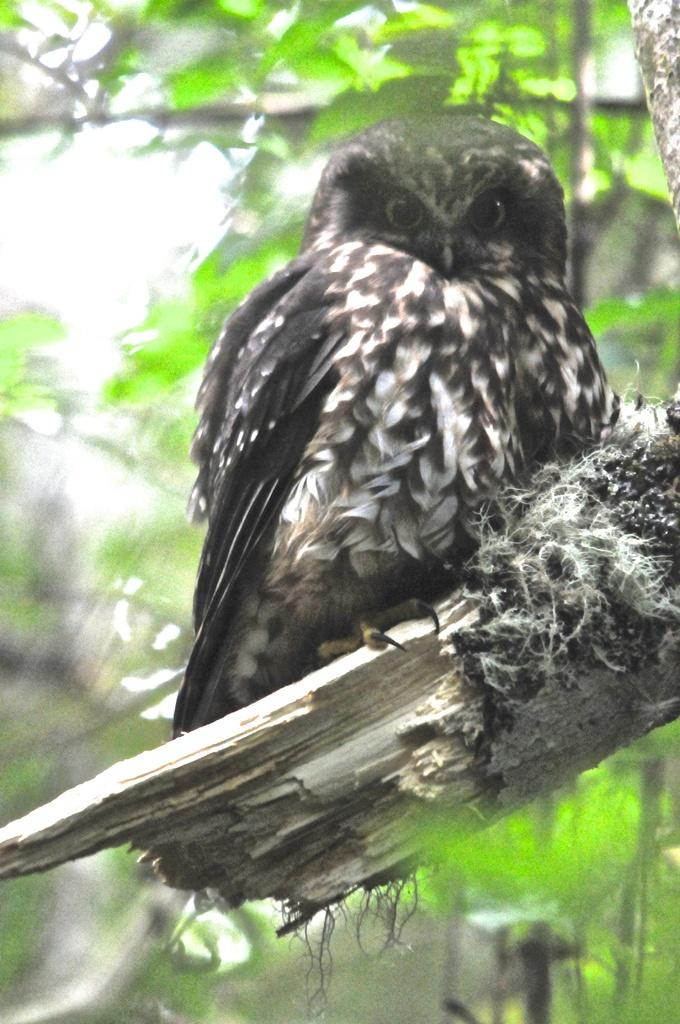What type of animal can be seen in the image? There is a bird in the image. What is the bird perched on? The bird is perched on a branch in the image. Can you describe the background of the image? The background of the image is blurry. What type of flower is growing on the ground in the image? There is no flower present in the image; it only features a bird perched on a branch with a blurry background. 